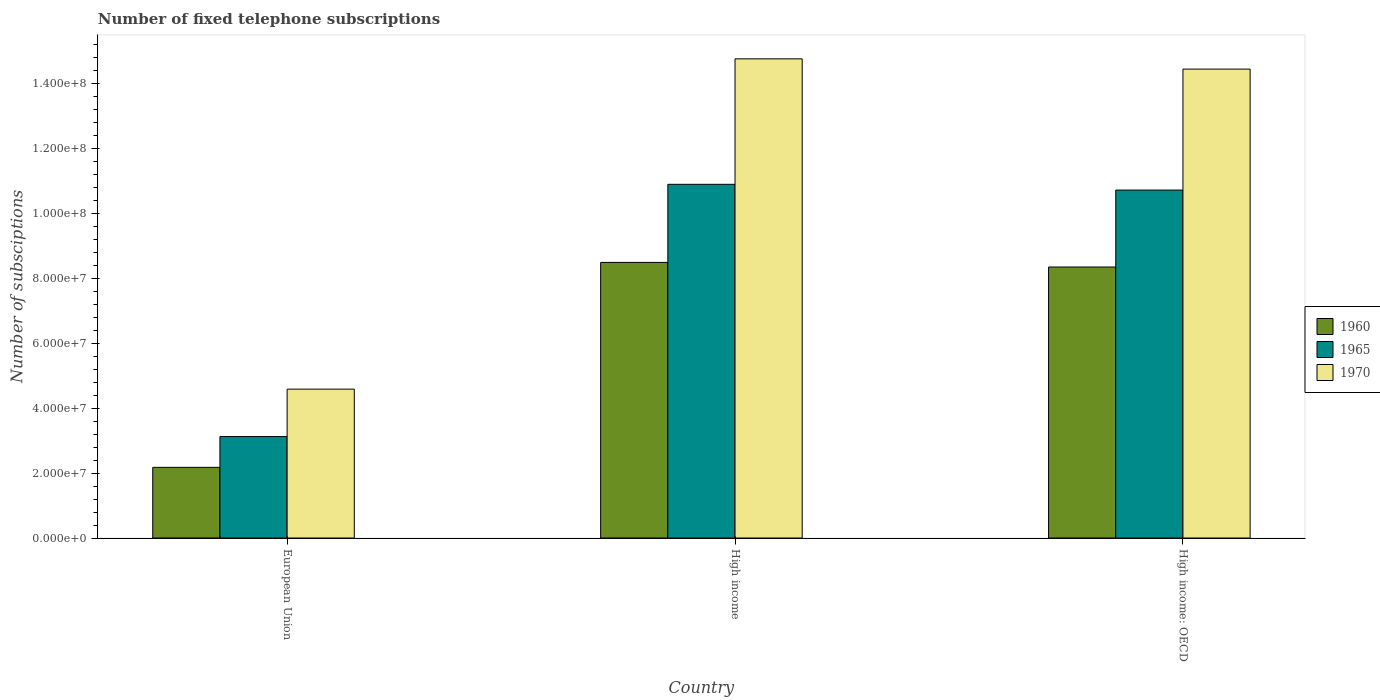How many different coloured bars are there?
Keep it short and to the point. 3. Are the number of bars per tick equal to the number of legend labels?
Provide a succinct answer. Yes. What is the label of the 3rd group of bars from the left?
Your answer should be very brief. High income: OECD. What is the number of fixed telephone subscriptions in 1960 in High income: OECD?
Keep it short and to the point. 8.35e+07. Across all countries, what is the maximum number of fixed telephone subscriptions in 1970?
Give a very brief answer. 1.48e+08. Across all countries, what is the minimum number of fixed telephone subscriptions in 1960?
Your answer should be very brief. 2.18e+07. In which country was the number of fixed telephone subscriptions in 1960 minimum?
Give a very brief answer. European Union. What is the total number of fixed telephone subscriptions in 1960 in the graph?
Give a very brief answer. 1.90e+08. What is the difference between the number of fixed telephone subscriptions in 1970 in High income and that in High income: OECD?
Your answer should be compact. 3.16e+06. What is the difference between the number of fixed telephone subscriptions in 1960 in High income: OECD and the number of fixed telephone subscriptions in 1965 in European Union?
Ensure brevity in your answer.  5.22e+07. What is the average number of fixed telephone subscriptions in 1970 per country?
Your answer should be compact. 1.13e+08. What is the difference between the number of fixed telephone subscriptions of/in 1960 and number of fixed telephone subscriptions of/in 1970 in European Union?
Provide a short and direct response. -2.41e+07. What is the ratio of the number of fixed telephone subscriptions in 1965 in European Union to that in High income: OECD?
Offer a terse response. 0.29. Is the number of fixed telephone subscriptions in 1970 in High income less than that in High income: OECD?
Your response must be concise. No. Is the difference between the number of fixed telephone subscriptions in 1960 in High income and High income: OECD greater than the difference between the number of fixed telephone subscriptions in 1970 in High income and High income: OECD?
Your answer should be compact. No. What is the difference between the highest and the second highest number of fixed telephone subscriptions in 1960?
Ensure brevity in your answer.  -6.17e+07. What is the difference between the highest and the lowest number of fixed telephone subscriptions in 1965?
Provide a succinct answer. 7.77e+07. In how many countries, is the number of fixed telephone subscriptions in 1965 greater than the average number of fixed telephone subscriptions in 1965 taken over all countries?
Your response must be concise. 2. Is the sum of the number of fixed telephone subscriptions in 1965 in High income and High income: OECD greater than the maximum number of fixed telephone subscriptions in 1970 across all countries?
Give a very brief answer. Yes. What does the 1st bar from the right in European Union represents?
Ensure brevity in your answer.  1970. Is it the case that in every country, the sum of the number of fixed telephone subscriptions in 1965 and number of fixed telephone subscriptions in 1970 is greater than the number of fixed telephone subscriptions in 1960?
Offer a terse response. Yes. How many bars are there?
Make the answer very short. 9. Are all the bars in the graph horizontal?
Give a very brief answer. No. How many countries are there in the graph?
Provide a short and direct response. 3. What is the difference between two consecutive major ticks on the Y-axis?
Provide a succinct answer. 2.00e+07. Where does the legend appear in the graph?
Provide a succinct answer. Center right. What is the title of the graph?
Your answer should be compact. Number of fixed telephone subscriptions. Does "2005" appear as one of the legend labels in the graph?
Give a very brief answer. No. What is the label or title of the Y-axis?
Make the answer very short. Number of subsciptions. What is the Number of subsciptions in 1960 in European Union?
Offer a terse response. 2.18e+07. What is the Number of subsciptions of 1965 in European Union?
Give a very brief answer. 3.12e+07. What is the Number of subsciptions of 1970 in European Union?
Offer a terse response. 4.59e+07. What is the Number of subsciptions of 1960 in High income?
Your answer should be very brief. 8.49e+07. What is the Number of subsciptions of 1965 in High income?
Your answer should be very brief. 1.09e+08. What is the Number of subsciptions in 1970 in High income?
Make the answer very short. 1.48e+08. What is the Number of subsciptions of 1960 in High income: OECD?
Offer a very short reply. 8.35e+07. What is the Number of subsciptions of 1965 in High income: OECD?
Ensure brevity in your answer.  1.07e+08. What is the Number of subsciptions of 1970 in High income: OECD?
Give a very brief answer. 1.44e+08. Across all countries, what is the maximum Number of subsciptions of 1960?
Offer a very short reply. 8.49e+07. Across all countries, what is the maximum Number of subsciptions of 1965?
Your answer should be compact. 1.09e+08. Across all countries, what is the maximum Number of subsciptions of 1970?
Your response must be concise. 1.48e+08. Across all countries, what is the minimum Number of subsciptions of 1960?
Provide a short and direct response. 2.18e+07. Across all countries, what is the minimum Number of subsciptions of 1965?
Your answer should be very brief. 3.12e+07. Across all countries, what is the minimum Number of subsciptions in 1970?
Offer a very short reply. 4.59e+07. What is the total Number of subsciptions of 1960 in the graph?
Make the answer very short. 1.90e+08. What is the total Number of subsciptions in 1965 in the graph?
Provide a short and direct response. 2.47e+08. What is the total Number of subsciptions of 1970 in the graph?
Provide a short and direct response. 3.38e+08. What is the difference between the Number of subsciptions in 1960 in European Union and that in High income?
Offer a terse response. -6.31e+07. What is the difference between the Number of subsciptions in 1965 in European Union and that in High income?
Your answer should be compact. -7.77e+07. What is the difference between the Number of subsciptions of 1970 in European Union and that in High income?
Provide a short and direct response. -1.02e+08. What is the difference between the Number of subsciptions in 1960 in European Union and that in High income: OECD?
Give a very brief answer. -6.17e+07. What is the difference between the Number of subsciptions of 1965 in European Union and that in High income: OECD?
Ensure brevity in your answer.  -7.59e+07. What is the difference between the Number of subsciptions of 1970 in European Union and that in High income: OECD?
Provide a succinct answer. -9.86e+07. What is the difference between the Number of subsciptions of 1960 in High income and that in High income: OECD?
Provide a succinct answer. 1.42e+06. What is the difference between the Number of subsciptions of 1965 in High income and that in High income: OECD?
Offer a very short reply. 1.77e+06. What is the difference between the Number of subsciptions in 1970 in High income and that in High income: OECD?
Your answer should be very brief. 3.16e+06. What is the difference between the Number of subsciptions in 1960 in European Union and the Number of subsciptions in 1965 in High income?
Your answer should be compact. -8.72e+07. What is the difference between the Number of subsciptions of 1960 in European Union and the Number of subsciptions of 1970 in High income?
Offer a terse response. -1.26e+08. What is the difference between the Number of subsciptions of 1965 in European Union and the Number of subsciptions of 1970 in High income?
Give a very brief answer. -1.16e+08. What is the difference between the Number of subsciptions in 1960 in European Union and the Number of subsciptions in 1965 in High income: OECD?
Keep it short and to the point. -8.54e+07. What is the difference between the Number of subsciptions of 1960 in European Union and the Number of subsciptions of 1970 in High income: OECD?
Provide a short and direct response. -1.23e+08. What is the difference between the Number of subsciptions of 1965 in European Union and the Number of subsciptions of 1970 in High income: OECD?
Ensure brevity in your answer.  -1.13e+08. What is the difference between the Number of subsciptions in 1960 in High income and the Number of subsciptions in 1965 in High income: OECD?
Make the answer very short. -2.23e+07. What is the difference between the Number of subsciptions in 1960 in High income and the Number of subsciptions in 1970 in High income: OECD?
Keep it short and to the point. -5.95e+07. What is the difference between the Number of subsciptions of 1965 in High income and the Number of subsciptions of 1970 in High income: OECD?
Give a very brief answer. -3.55e+07. What is the average Number of subsciptions of 1960 per country?
Ensure brevity in your answer.  6.34e+07. What is the average Number of subsciptions in 1965 per country?
Give a very brief answer. 8.24e+07. What is the average Number of subsciptions in 1970 per country?
Give a very brief answer. 1.13e+08. What is the difference between the Number of subsciptions in 1960 and Number of subsciptions in 1965 in European Union?
Provide a succinct answer. -9.48e+06. What is the difference between the Number of subsciptions of 1960 and Number of subsciptions of 1970 in European Union?
Keep it short and to the point. -2.41e+07. What is the difference between the Number of subsciptions in 1965 and Number of subsciptions in 1970 in European Union?
Offer a very short reply. -1.46e+07. What is the difference between the Number of subsciptions of 1960 and Number of subsciptions of 1965 in High income?
Provide a succinct answer. -2.41e+07. What is the difference between the Number of subsciptions of 1960 and Number of subsciptions of 1970 in High income?
Keep it short and to the point. -6.27e+07. What is the difference between the Number of subsciptions of 1965 and Number of subsciptions of 1970 in High income?
Your answer should be compact. -3.86e+07. What is the difference between the Number of subsciptions of 1960 and Number of subsciptions of 1965 in High income: OECD?
Keep it short and to the point. -2.37e+07. What is the difference between the Number of subsciptions of 1960 and Number of subsciptions of 1970 in High income: OECD?
Your response must be concise. -6.10e+07. What is the difference between the Number of subsciptions of 1965 and Number of subsciptions of 1970 in High income: OECD?
Give a very brief answer. -3.73e+07. What is the ratio of the Number of subsciptions of 1960 in European Union to that in High income?
Give a very brief answer. 0.26. What is the ratio of the Number of subsciptions in 1965 in European Union to that in High income?
Your answer should be compact. 0.29. What is the ratio of the Number of subsciptions in 1970 in European Union to that in High income?
Provide a short and direct response. 0.31. What is the ratio of the Number of subsciptions in 1960 in European Union to that in High income: OECD?
Ensure brevity in your answer.  0.26. What is the ratio of the Number of subsciptions in 1965 in European Union to that in High income: OECD?
Provide a succinct answer. 0.29. What is the ratio of the Number of subsciptions in 1970 in European Union to that in High income: OECD?
Provide a succinct answer. 0.32. What is the ratio of the Number of subsciptions of 1960 in High income to that in High income: OECD?
Give a very brief answer. 1.02. What is the ratio of the Number of subsciptions of 1965 in High income to that in High income: OECD?
Give a very brief answer. 1.02. What is the ratio of the Number of subsciptions in 1970 in High income to that in High income: OECD?
Provide a succinct answer. 1.02. What is the difference between the highest and the second highest Number of subsciptions of 1960?
Offer a terse response. 1.42e+06. What is the difference between the highest and the second highest Number of subsciptions of 1965?
Provide a succinct answer. 1.77e+06. What is the difference between the highest and the second highest Number of subsciptions of 1970?
Give a very brief answer. 3.16e+06. What is the difference between the highest and the lowest Number of subsciptions of 1960?
Offer a terse response. 6.31e+07. What is the difference between the highest and the lowest Number of subsciptions of 1965?
Provide a short and direct response. 7.77e+07. What is the difference between the highest and the lowest Number of subsciptions of 1970?
Keep it short and to the point. 1.02e+08. 